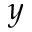Convert formula to latex. <formula><loc_0><loc_0><loc_500><loc_500>y</formula> 